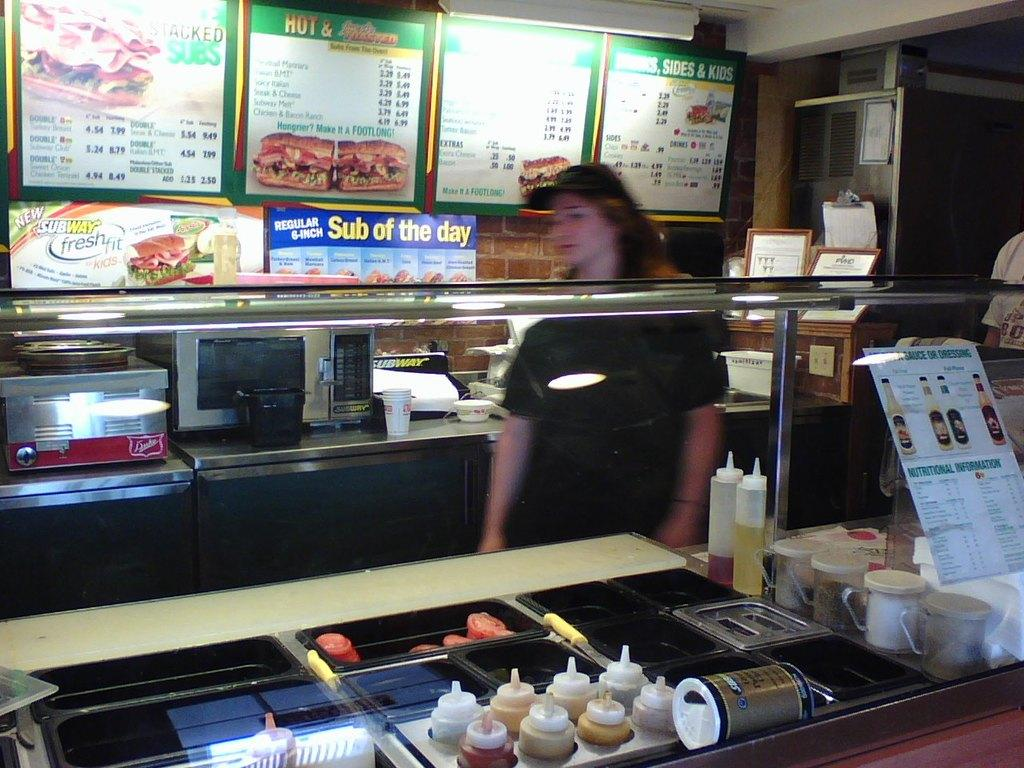<image>
Summarize the visual content of the image. a subway store with a female employee working 